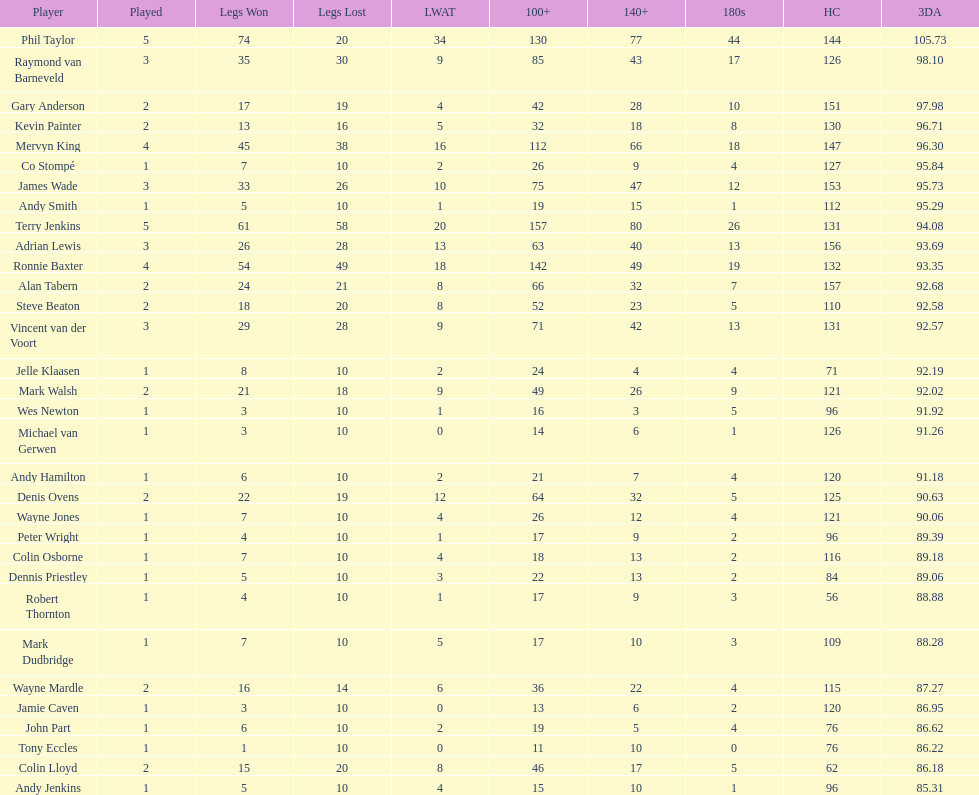I'm looking to parse the entire table for insights. Could you assist me with that? {'header': ['Player', 'Played', 'Legs Won', 'Legs Lost', 'LWAT', '100+', '140+', '180s', 'HC', '3DA'], 'rows': [['Phil Taylor', '5', '74', '20', '34', '130', '77', '44', '144', '105.73'], ['Raymond van Barneveld', '3', '35', '30', '9', '85', '43', '17', '126', '98.10'], ['Gary Anderson', '2', '17', '19', '4', '42', '28', '10', '151', '97.98'], ['Kevin Painter', '2', '13', '16', '5', '32', '18', '8', '130', '96.71'], ['Mervyn King', '4', '45', '38', '16', '112', '66', '18', '147', '96.30'], ['Co Stompé', '1', '7', '10', '2', '26', '9', '4', '127', '95.84'], ['James Wade', '3', '33', '26', '10', '75', '47', '12', '153', '95.73'], ['Andy Smith', '1', '5', '10', '1', '19', '15', '1', '112', '95.29'], ['Terry Jenkins', '5', '61', '58', '20', '157', '80', '26', '131', '94.08'], ['Adrian Lewis', '3', '26', '28', '13', '63', '40', '13', '156', '93.69'], ['Ronnie Baxter', '4', '54', '49', '18', '142', '49', '19', '132', '93.35'], ['Alan Tabern', '2', '24', '21', '8', '66', '32', '7', '157', '92.68'], ['Steve Beaton', '2', '18', '20', '8', '52', '23', '5', '110', '92.58'], ['Vincent van der Voort', '3', '29', '28', '9', '71', '42', '13', '131', '92.57'], ['Jelle Klaasen', '1', '8', '10', '2', '24', '4', '4', '71', '92.19'], ['Mark Walsh', '2', '21', '18', '9', '49', '26', '9', '121', '92.02'], ['Wes Newton', '1', '3', '10', '1', '16', '3', '5', '96', '91.92'], ['Michael van Gerwen', '1', '3', '10', '0', '14', '6', '1', '126', '91.26'], ['Andy Hamilton', '1', '6', '10', '2', '21', '7', '4', '120', '91.18'], ['Denis Ovens', '2', '22', '19', '12', '64', '32', '5', '125', '90.63'], ['Wayne Jones', '1', '7', '10', '4', '26', '12', '4', '121', '90.06'], ['Peter Wright', '1', '4', '10', '1', '17', '9', '2', '96', '89.39'], ['Colin Osborne', '1', '7', '10', '4', '18', '13', '2', '116', '89.18'], ['Dennis Priestley', '1', '5', '10', '3', '22', '13', '2', '84', '89.06'], ['Robert Thornton', '1', '4', '10', '1', '17', '9', '3', '56', '88.88'], ['Mark Dudbridge', '1', '7', '10', '5', '17', '10', '3', '109', '88.28'], ['Wayne Mardle', '2', '16', '14', '6', '36', '22', '4', '115', '87.27'], ['Jamie Caven', '1', '3', '10', '0', '13', '6', '2', '120', '86.95'], ['John Part', '1', '6', '10', '2', '19', '5', '4', '76', '86.62'], ['Tony Eccles', '1', '1', '10', '0', '11', '10', '0', '76', '86.22'], ['Colin Lloyd', '2', '15', '20', '8', '46', '17', '5', '62', '86.18'], ['Andy Jenkins', '1', '5', '10', '4', '15', '10', '1', '96', '85.31']]} What is the name of the next player after mark walsh? Wes Newton. 